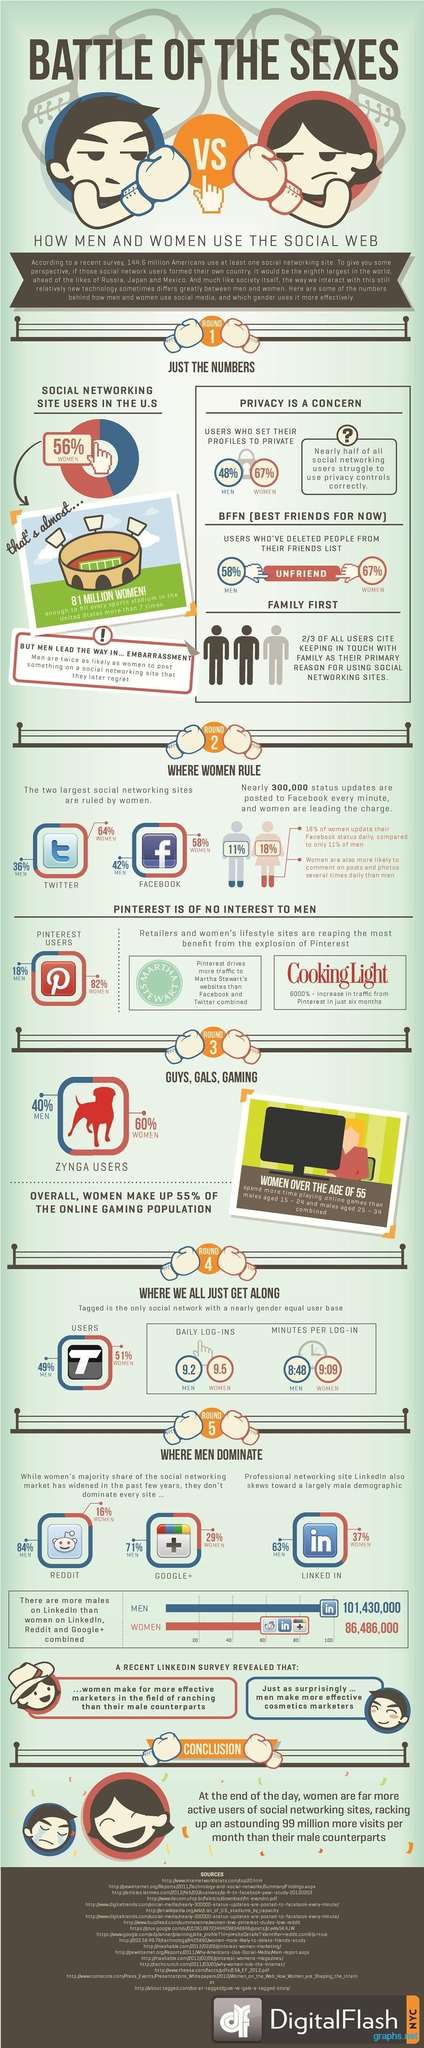What percentage of facebook users in America are women as per the survey?
Answer the question with a short phrase. 58% How many men are Linkedin users in America according to the survey? 101,430,000 How many minutes per log-in is spend by female 'tagged' users in America according to the survey? 9:09 What percentage of Twitter users in America are men as per the survey? 36% What percentage of Zynga users in America are women? 60% 